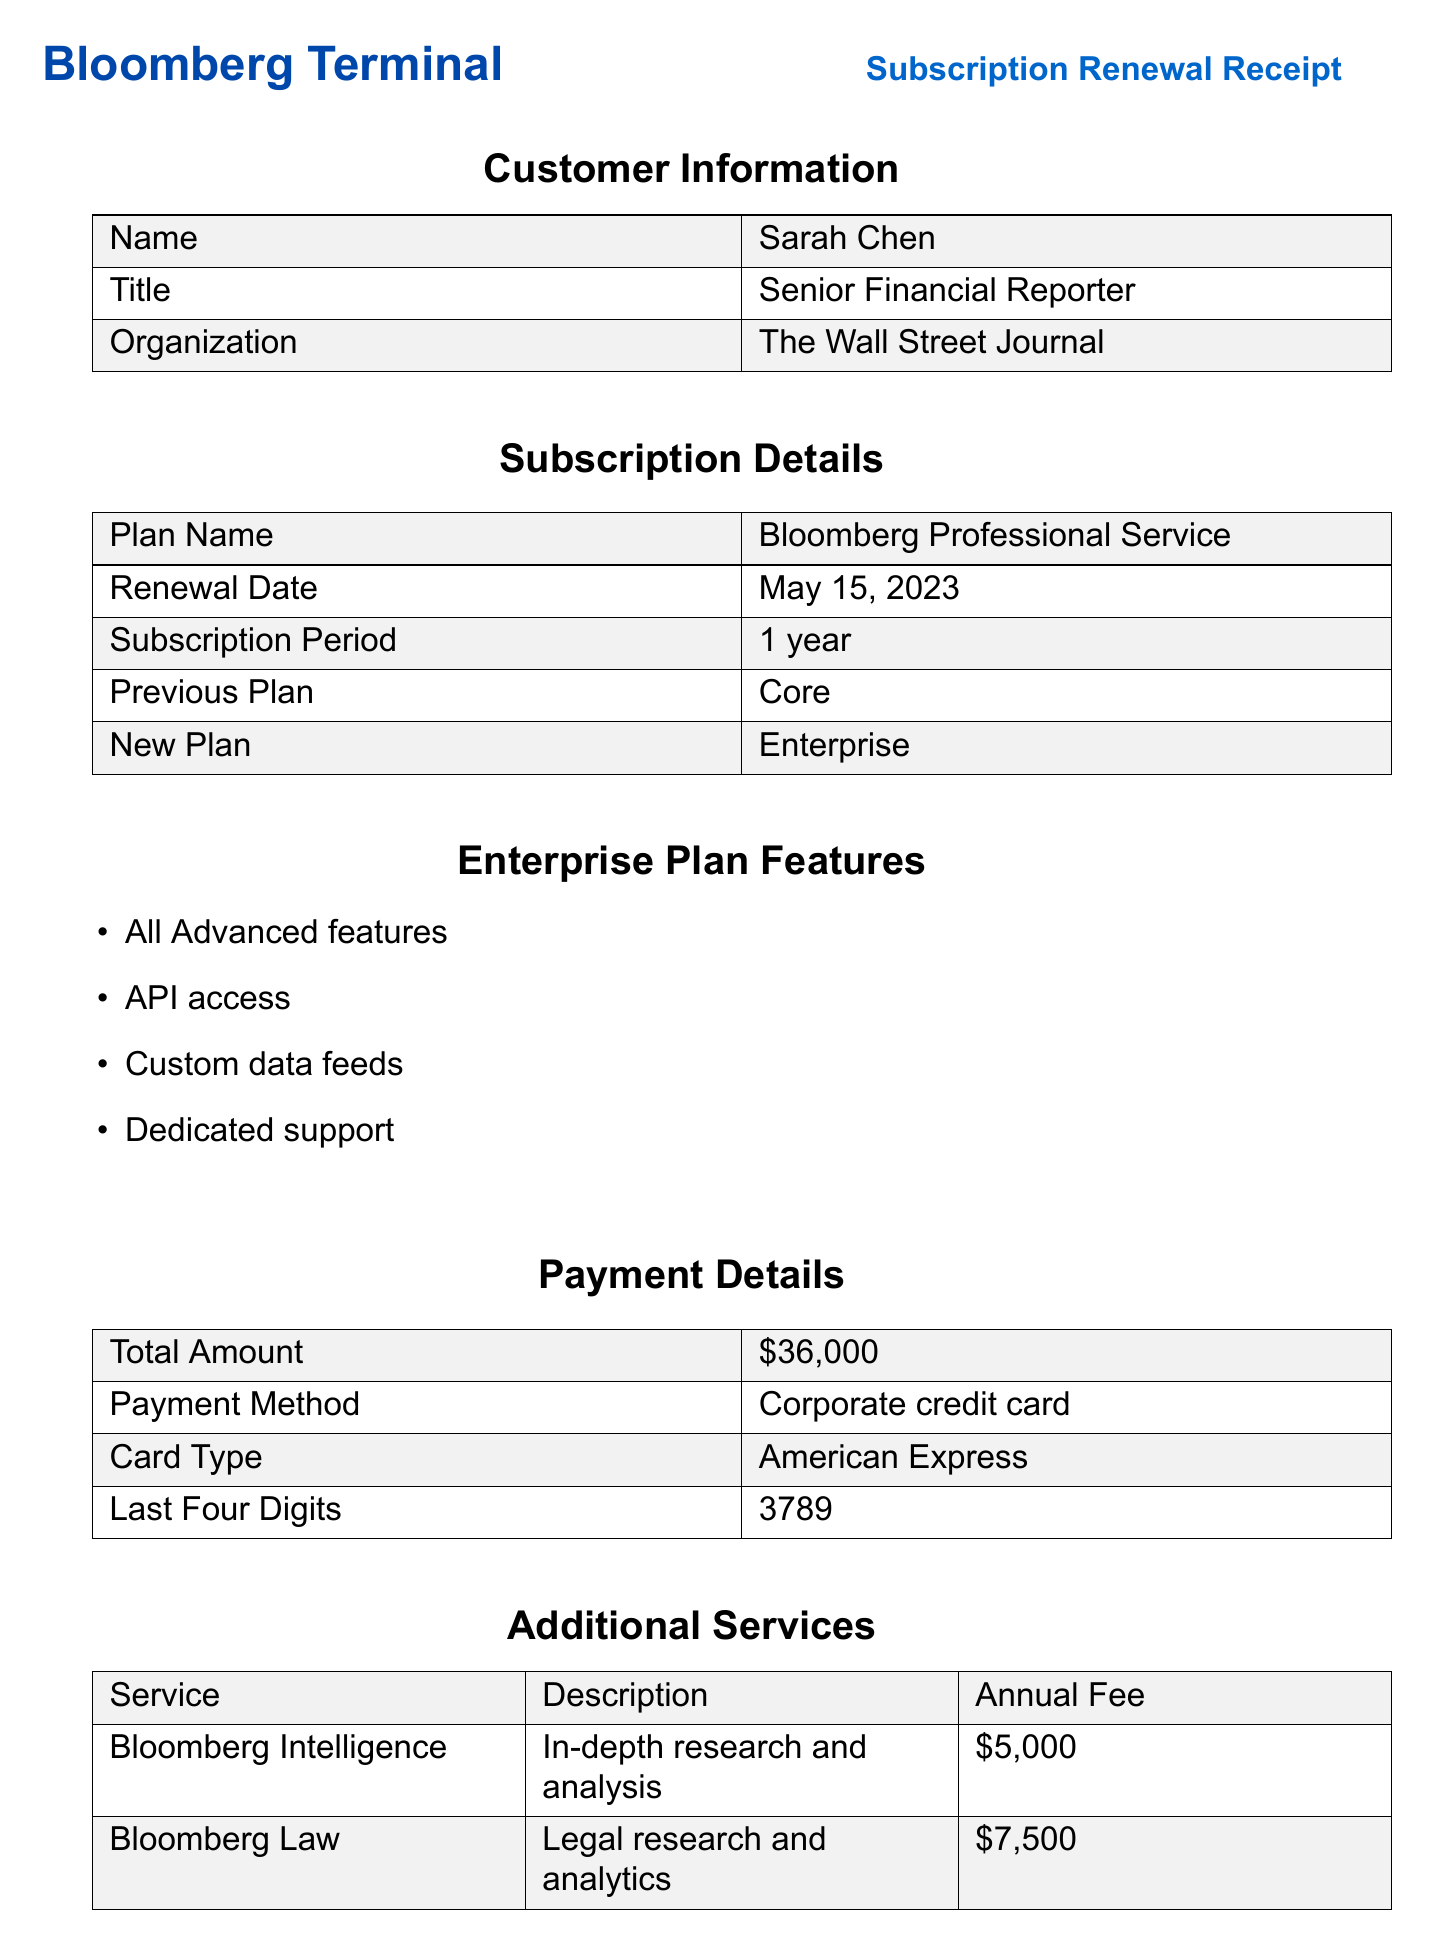what is the customer name? The customer name is clearly mentioned in the document under customer information.
Answer: Sarah Chen what is the total amount for the subscription renewal? The total amount is specified in the payment details section of the document.
Answer: $36,000 what is the renewal date? The renewal date is listed under subscription details.
Answer: May 15, 2023 how many concurrent users does the Enterprise plan allow? The access levels indicate that the Enterprise plan has unlimited concurrent users.
Answer: Unlimited what are the additional services listed in the receipt? The document provides specific additional services along with their descriptions and annual fees.
Answer: Bloomberg Intelligence, Bloomberg Law what was the previous subscription plan? The previous plan is mentioned in the subscription details section.
Answer: Core what payment method was used for the renewal? The payment method is outlined in the payment details section.
Answer: Corporate credit card which features are included in the Enterprise plan? The document lists the features included in the Enterprise plan.
Answer: API access, Custom data feeds, Dedicated support what is the annual fee for Bloomberg Law? The annual fee for Bloomberg Law is specified in the additional services section.
Answer: $7,500 